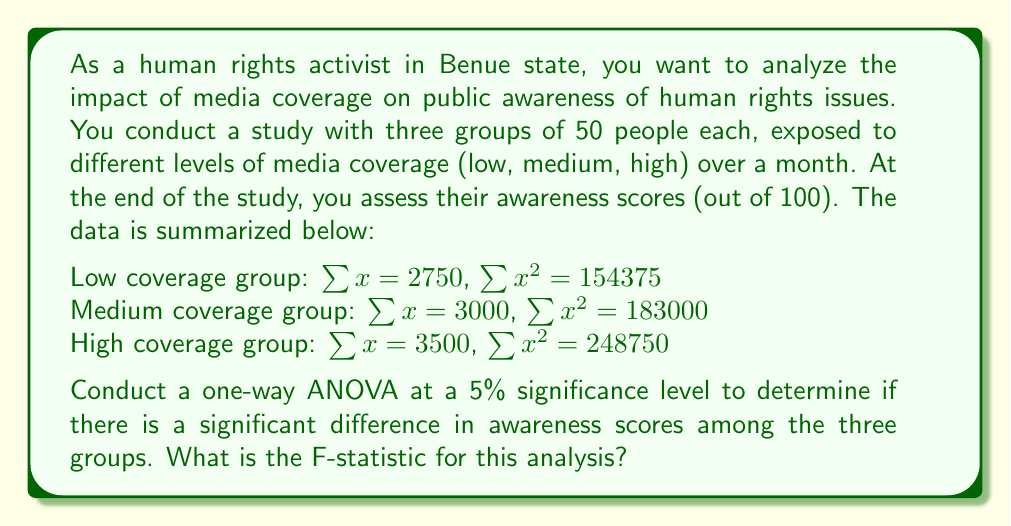Can you answer this question? To conduct a one-way ANOVA, we need to follow these steps:

1. Calculate the sum of squares between groups (SSB) and within groups (SSW)
2. Calculate the degrees of freedom for between groups (dfB) and within groups (dfW)
3. Calculate the mean square between groups (MSB) and within groups (MSW)
4. Calculate the F-statistic

Step 1: Calculate SSB and SSW

First, we need to calculate the total sum of squares (SST):

$SST = \sum x^2 - \frac{(\sum x)^2}{N}$

Where $N$ is the total number of observations (150 in this case).

$SST = (154375 + 183000 + 248750) - \frac{(2750 + 3000 + 3500)^2}{150}$
$SST = 586125 - \frac{9250^2}{150} = 586125 - 570416.67 = 15708.33$

Now, we calculate SSB:

$SSB = \sum \frac{T_i^2}{n_i} - \frac{(\sum x)^2}{N}$

Where $T_i$ is the sum of scores for each group and $n_i$ is the number of observations in each group (50).

$SSB = \frac{2750^2}{50} + \frac{3000^2}{50} + \frac{3500^2}{50} - \frac{9250^2}{150}$
$SSB = 151250 + 180000 + 245000 - 570416.67 = 5833.33$

SSW is the difference between SST and SSB:

$SSW = SST - SSB = 15708.33 - 5833.33 = 9875$

Step 2: Calculate degrees of freedom

$dfB = k - 1 = 3 - 1 = 2$ (where k is the number of groups)
$dfW = N - k = 150 - 3 = 147$

Step 3: Calculate mean squares

$MSB = \frac{SSB}{dfB} = \frac{5833.33}{2} = 2916.67$
$MSW = \frac{SSW}{dfW} = \frac{9875}{147} = 67.18$

Step 4: Calculate F-statistic

$F = \frac{MSB}{MSW} = \frac{2916.67}{67.18} = 43.42$
Answer: The F-statistic for this one-way ANOVA is 43.42. 